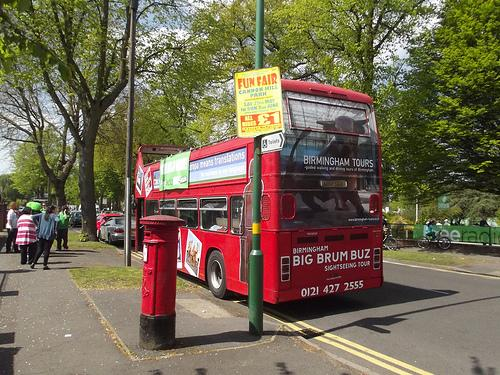Provide information about people's clothing and their location in the image. People, wearing a blue sweater or a white and pink striped shirt, are standing on the sidewalk. Assess the overall sentiment and atmosphere within the image. The sentiment is generally positive, with people going about their daily activities on a lively city street. Name the colors of the trees and mention the color of grass. The trees are green and brown, and the grass is green. What color is the pole and what type of sign is posted on it? The pole is green, and a yellow poster sign displaying "Fun Fair" is posted on it. Describe the interaction between people and the bus. People are standing nearby, possibly loading onto the bus, which seems to be waiting at a bus stop. What type of bus is depicted in the image and what color is it? The bus is a red double-decker bus waiting for passengers. Describe the overall appearance of the street in the image. The street has a yellow line, cars parked near the sidewalk, tall green trees, and a bus stop with a red double-decker bus. Detail the textual and image content on the bus. The bus has an advertisement all over it, white letters, an image of an animal, and a banner promoting Fun Fair. Mention the location of a bike in the image and identify what action is taking place in the park. A bike is parked across the street, and people are riding bicycles in the park. Count the objects related to the bus, such as wheels, windows, and lights. There are 2 wheels, multiple windows, and a set of lights on the bus. 